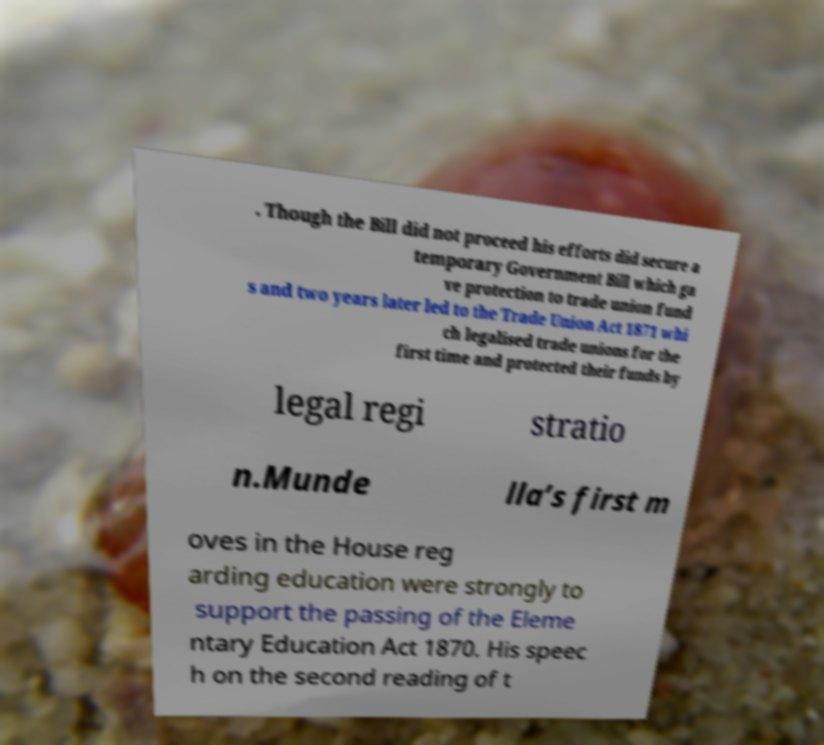There's text embedded in this image that I need extracted. Can you transcribe it verbatim? . Though the Bill did not proceed his efforts did secure a temporary Government Bill which ga ve protection to trade union fund s and two years later led to the Trade Union Act 1871 whi ch legalised trade unions for the first time and protected their funds by legal regi stratio n.Munde lla’s first m oves in the House reg arding education were strongly to support the passing of the Eleme ntary Education Act 1870. His speec h on the second reading of t 